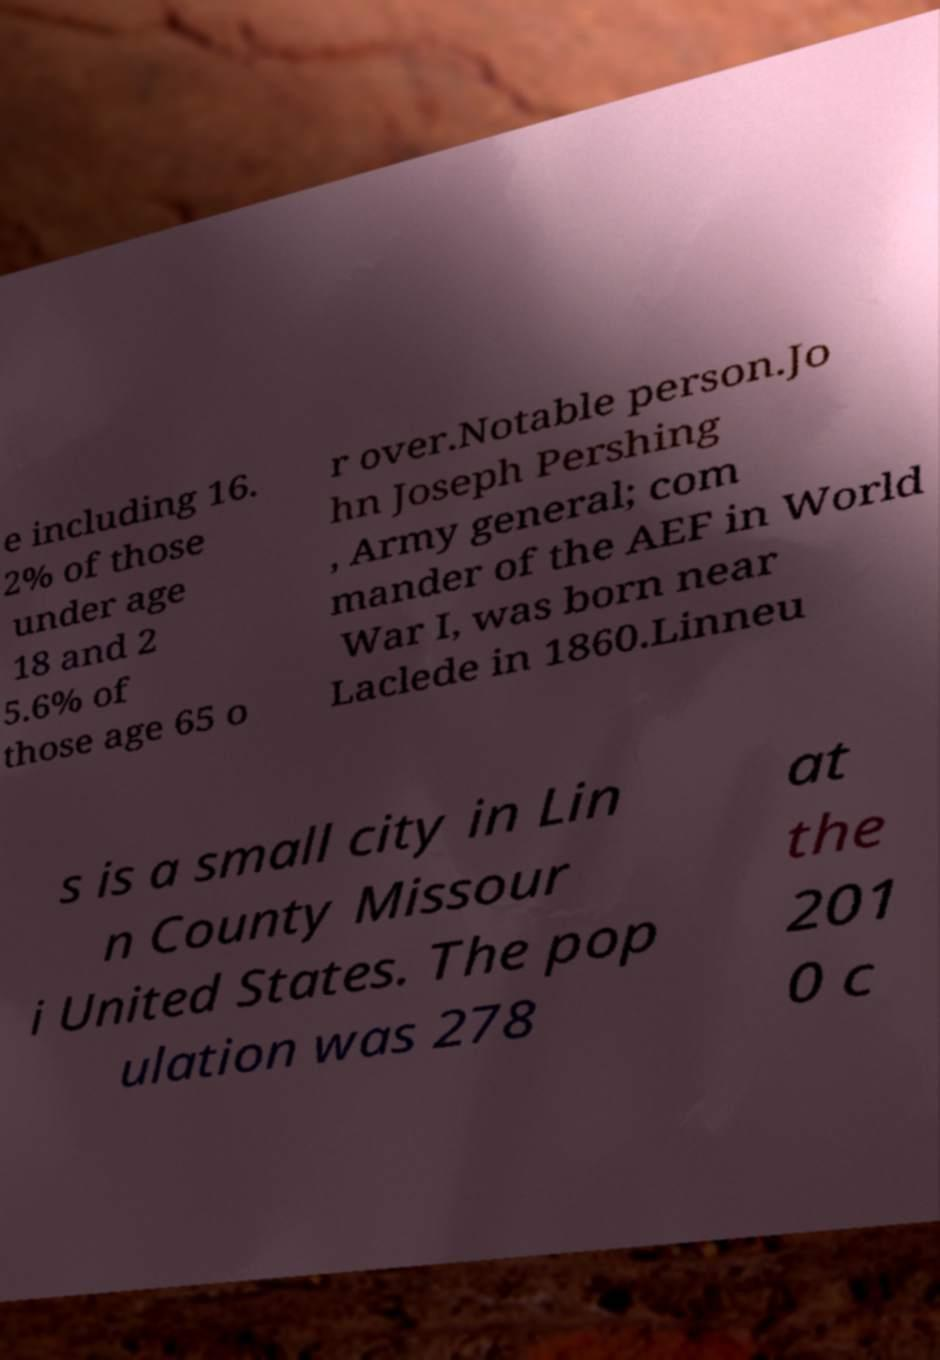For documentation purposes, I need the text within this image transcribed. Could you provide that? e including 16. 2% of those under age 18 and 2 5.6% of those age 65 o r over.Notable person.Jo hn Joseph Pershing , Army general; com mander of the AEF in World War I, was born near Laclede in 1860.Linneu s is a small city in Lin n County Missour i United States. The pop ulation was 278 at the 201 0 c 